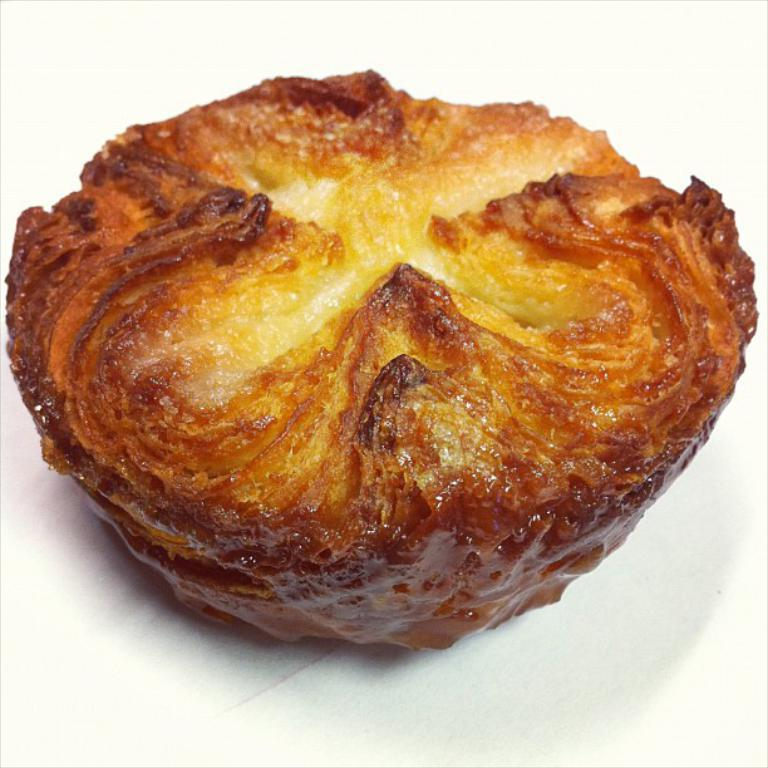What is the main subject of the image? There is a food item in the image. Can you describe the surface on which the food item is placed? The food item is on a white surface. What type of act is the food item performing in the image? The food item is not performing any act in the image, as it is an inanimate object. What season is depicted in the image? The season is not depicted in the image, as there are no seasonal indicators present. 